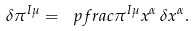<formula> <loc_0><loc_0><loc_500><loc_500>\delta \pi ^ { I \mu } = \ p f r a c { \pi ^ { I \mu } } { x ^ { \alpha } } \, \delta x ^ { \alpha } .</formula> 